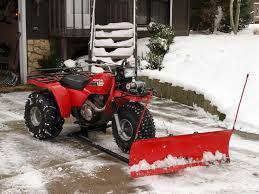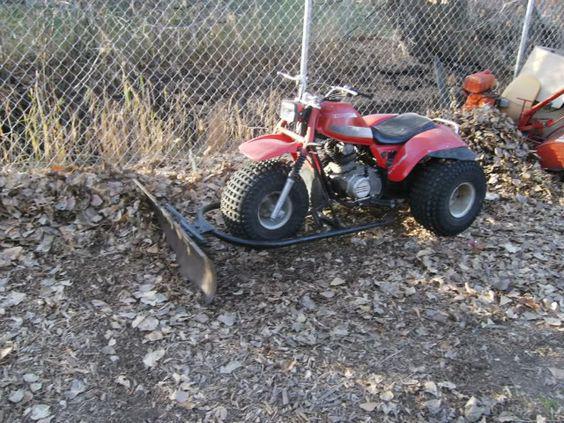The first image is the image on the left, the second image is the image on the right. Analyze the images presented: Is the assertion "There is a human in each image." valid? Answer yes or no. No. The first image is the image on the left, the second image is the image on the right. Examine the images to the left and right. Is the description "Each red three wheeler snowplow is being operated by a rider." accurate? Answer yes or no. No. 